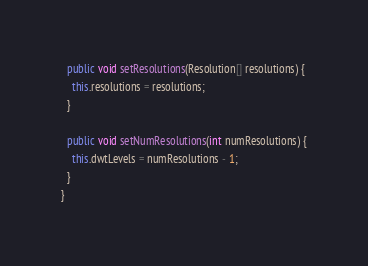<code> <loc_0><loc_0><loc_500><loc_500><_Java_>
  public void setResolutions(Resolution[] resolutions) {
    this.resolutions = resolutions;
  }

  public void setNumResolutions(int numResolutions) {
    this.dwtLevels = numResolutions - 1;
  }
}
</code> 